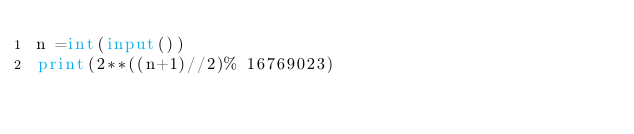<code> <loc_0><loc_0><loc_500><loc_500><_Python_>n =int(input())
print(2**((n+1)//2)% 16769023)</code> 